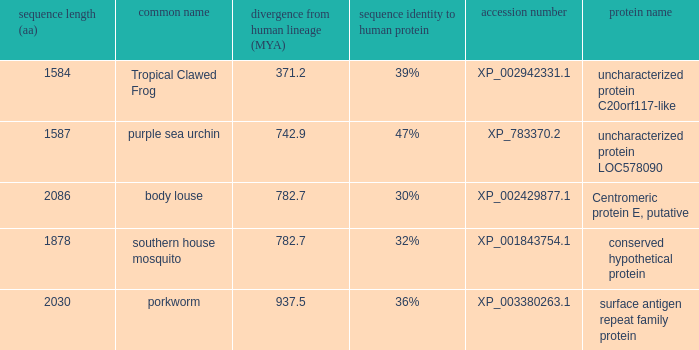What is the accession number of the protein with a divergence from human lineage of 937.5? XP_003380263.1. 